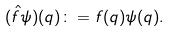Convert formula to latex. <formula><loc_0><loc_0><loc_500><loc_500>( \hat { f } \psi ) ( q ) \colon = f ( q ) \psi ( q ) .</formula> 